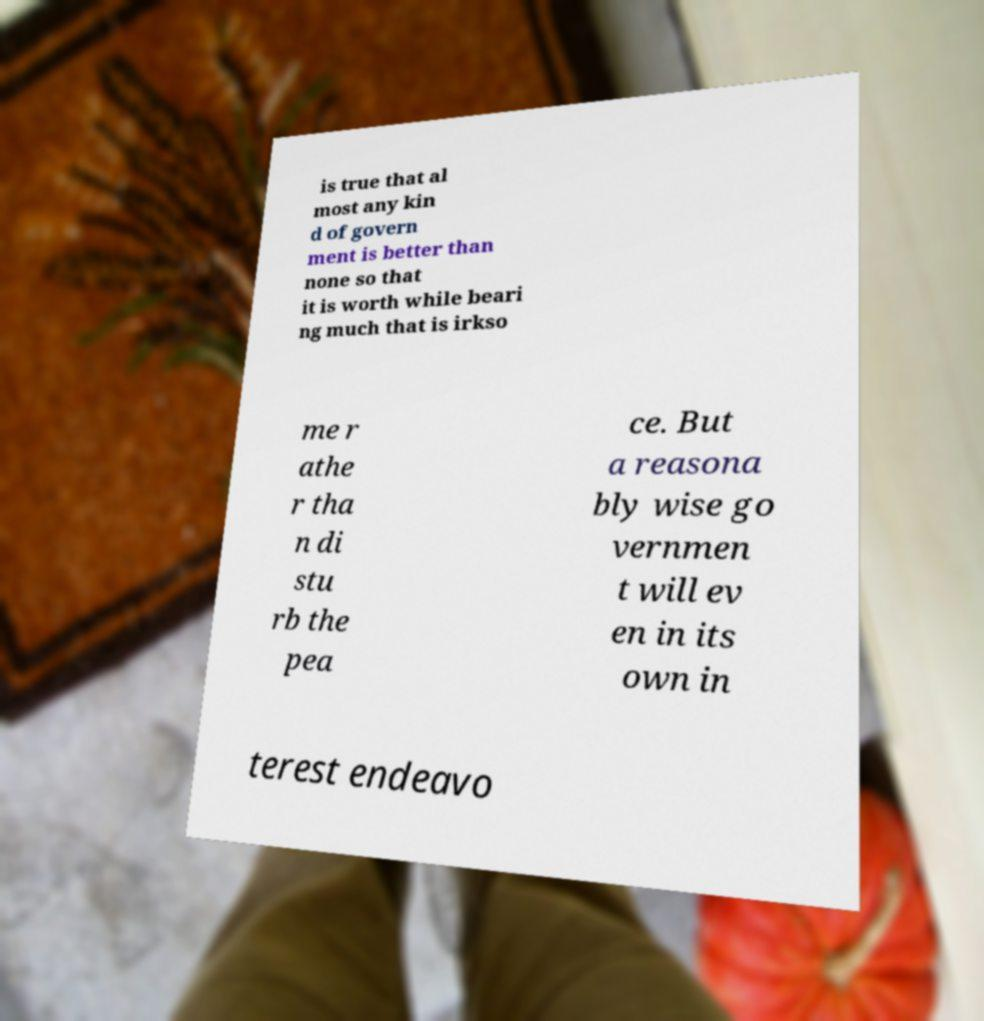What messages or text are displayed in this image? I need them in a readable, typed format. is true that al most any kin d of govern ment is better than none so that it is worth while beari ng much that is irkso me r athe r tha n di stu rb the pea ce. But a reasona bly wise go vernmen t will ev en in its own in terest endeavo 